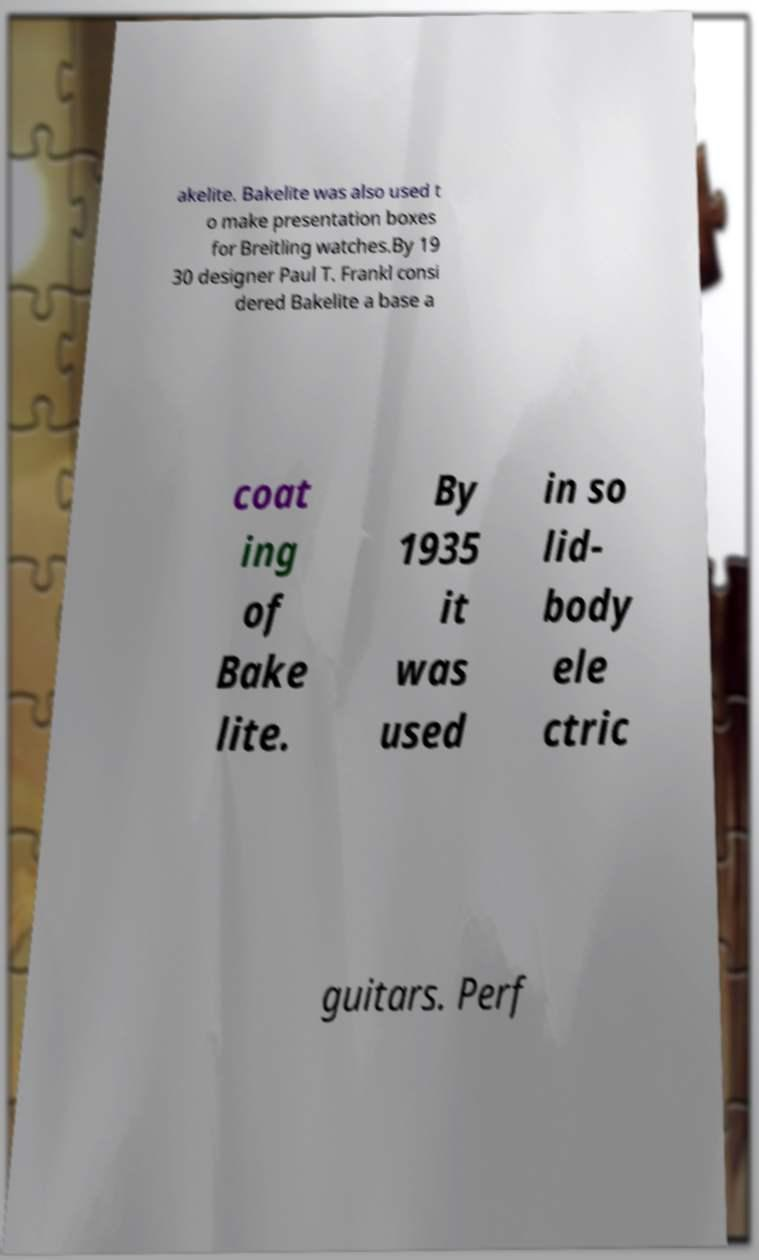Please identify and transcribe the text found in this image. akelite. Bakelite was also used t o make presentation boxes for Breitling watches.By 19 30 designer Paul T. Frankl consi dered Bakelite a base a coat ing of Bake lite. By 1935 it was used in so lid- body ele ctric guitars. Perf 